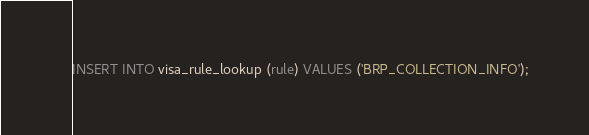<code> <loc_0><loc_0><loc_500><loc_500><_SQL_>INSERT INTO visa_rule_lookup (rule) VALUES ('BRP_COLLECTION_INFO');</code> 